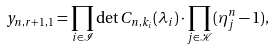<formula> <loc_0><loc_0><loc_500><loc_500>y _ { n , r + 1 , 1 } = \prod _ { i \in \mathcal { I } } \det C _ { n , k _ { i } } ( \lambda _ { i } ) \cdot \prod _ { j \in \mathcal { K } } ( \eta _ { j } ^ { n } - 1 ) ,</formula> 